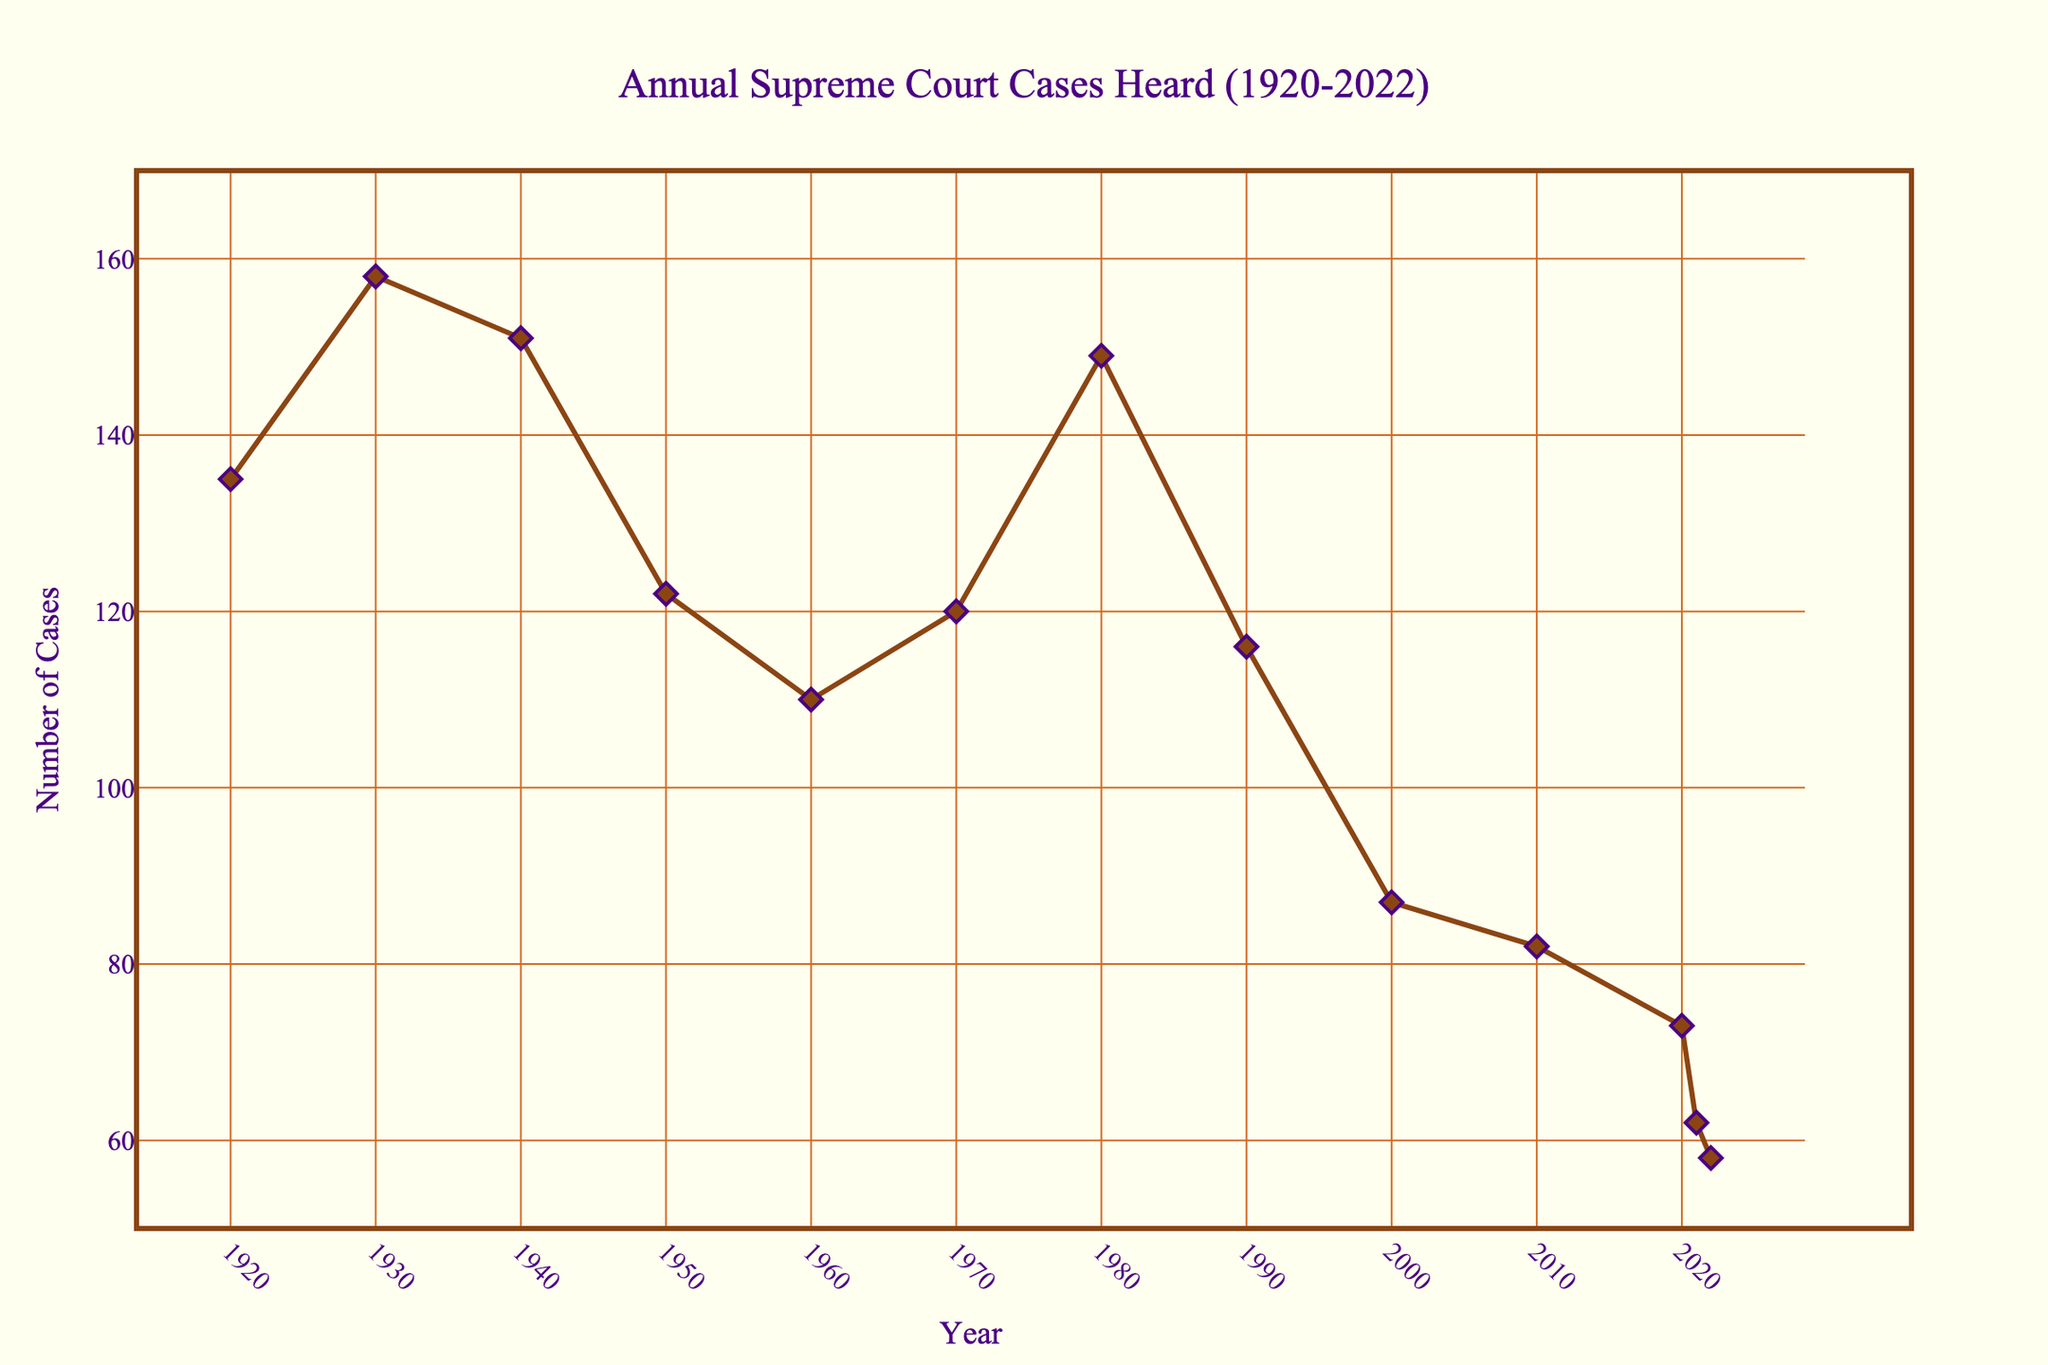compositional questions explanation
Answer: concise answer What is the average number of cases heard per year in the 1950s? To find the average for the 1950s, consider the number of cases from 1950 and 1960. The number of cases heard in 1950 is 122 and in 1960 is 110. The average is (122 + 110) / 2 = 116.
Answer: 116 What is the difference in the number of cases heard between 1920 and 2022? Refer to the figure and note the data for 1920 (135 cases) and 2022 (58 cases). The difference is 135 - 58 = 77.
Answer: 77 What’s the average number of cases heard per decade from 1920 to 1930? Check the data for 1920 (135 cases) and 1930 (158 cases). The average is (135 + 158) / 2 = 146.5.
Answer: 146.5 comparison questions explanation
Answer: concise answer Which year had the highest number of cases heard? From the figure, identify the highest point on the line, which corresponds to 1930 with 158 cases.
Answer: 1930 Which year had fewer cases heard: 1980 or 1990? Compare the data for 1980 (149 cases) and 1990 (116 cases). 1990 had fewer cases.
Answer: 1990 Has the number of cases heard in 2022 increased or decreased compared to the 2010 figure? Compare the 2022 data (58 cases) to the 2010 data (82 cases). The number of cases decreased in 2022.
Answer: Decreased visual questions explanation
Answer: concise answer What marker style is used to represent the data points? The markers are diamonds with a size of 10, featuring a line around them.
Answer: Diamonds What is the background color of the plot area? The plot area and the paper background are both colored ivory.
Answer: Ivory What is the color of the line representing the cases heard each year? The line is brown.
Answer: Brown 